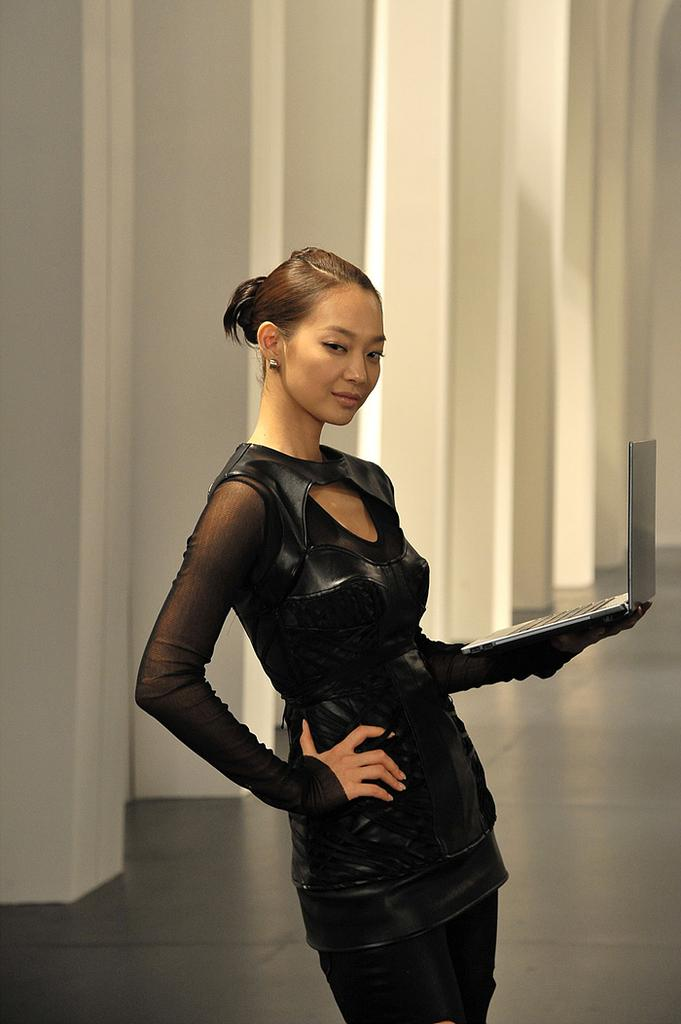What can be seen in the image? There is a person in the image. What is the person doing in the image? The person is holding an object and standing. What can be seen beneath the person's feet in the image? The ground is visible in the image. What color is the background of the image? The background of the image is white. What advice does the person in the image give to the viewer? There is no indication in the image that the person is giving advice to the viewer. 